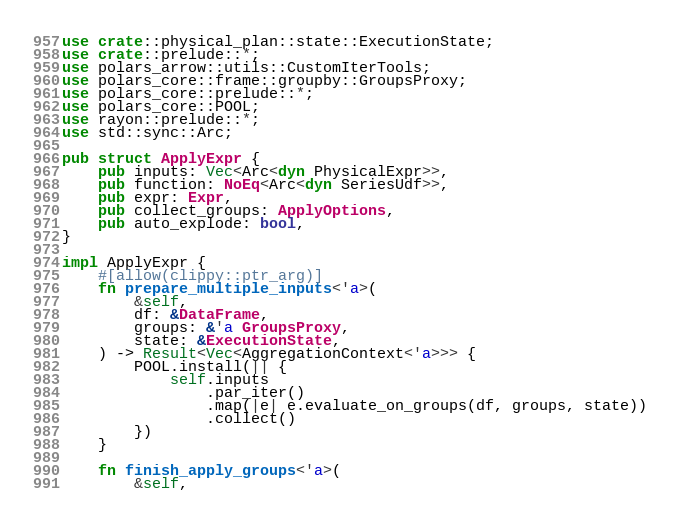Convert code to text. <code><loc_0><loc_0><loc_500><loc_500><_Rust_>use crate::physical_plan::state::ExecutionState;
use crate::prelude::*;
use polars_arrow::utils::CustomIterTools;
use polars_core::frame::groupby::GroupsProxy;
use polars_core::prelude::*;
use polars_core::POOL;
use rayon::prelude::*;
use std::sync::Arc;

pub struct ApplyExpr {
    pub inputs: Vec<Arc<dyn PhysicalExpr>>,
    pub function: NoEq<Arc<dyn SeriesUdf>>,
    pub expr: Expr,
    pub collect_groups: ApplyOptions,
    pub auto_explode: bool,
}

impl ApplyExpr {
    #[allow(clippy::ptr_arg)]
    fn prepare_multiple_inputs<'a>(
        &self,
        df: &DataFrame,
        groups: &'a GroupsProxy,
        state: &ExecutionState,
    ) -> Result<Vec<AggregationContext<'a>>> {
        POOL.install(|| {
            self.inputs
                .par_iter()
                .map(|e| e.evaluate_on_groups(df, groups, state))
                .collect()
        })
    }

    fn finish_apply_groups<'a>(
        &self,</code> 